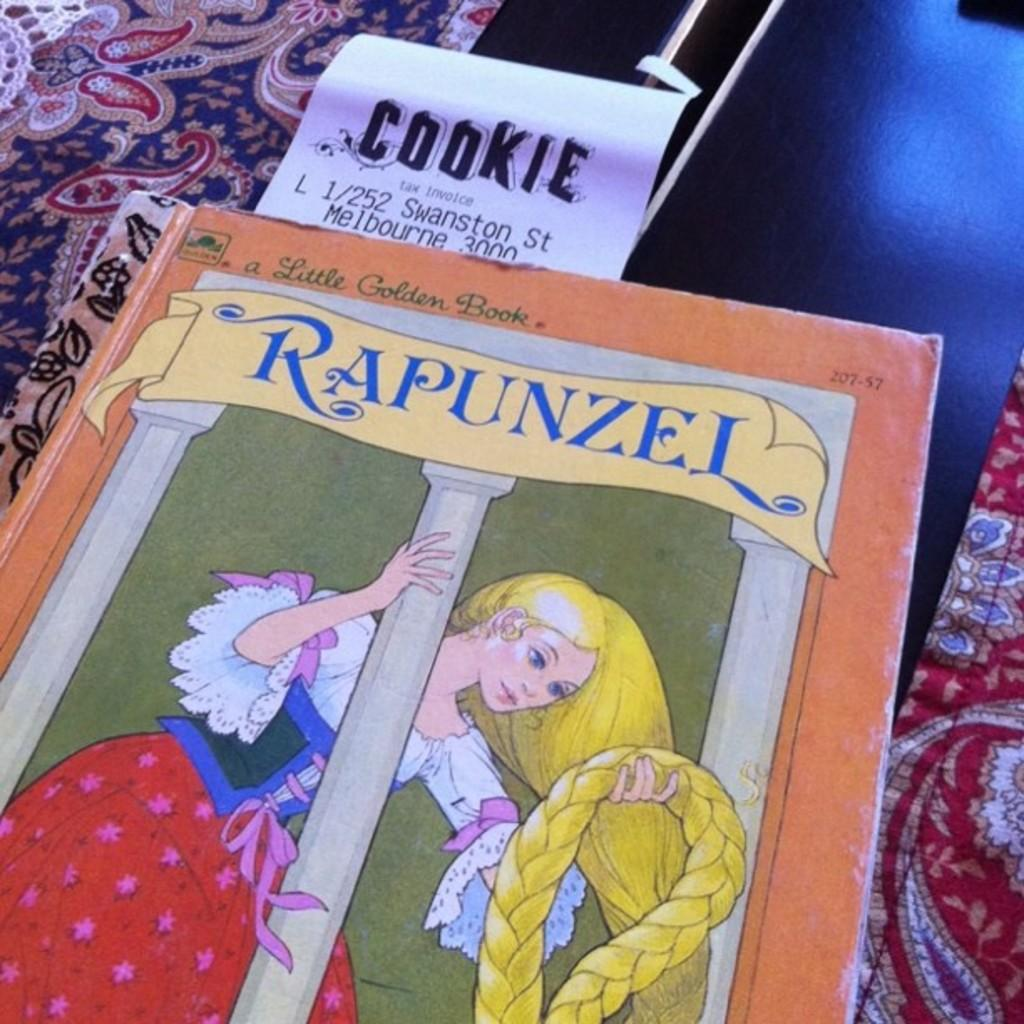<image>
Describe the image concisely. The cover of the children's book story Rapunzel. 